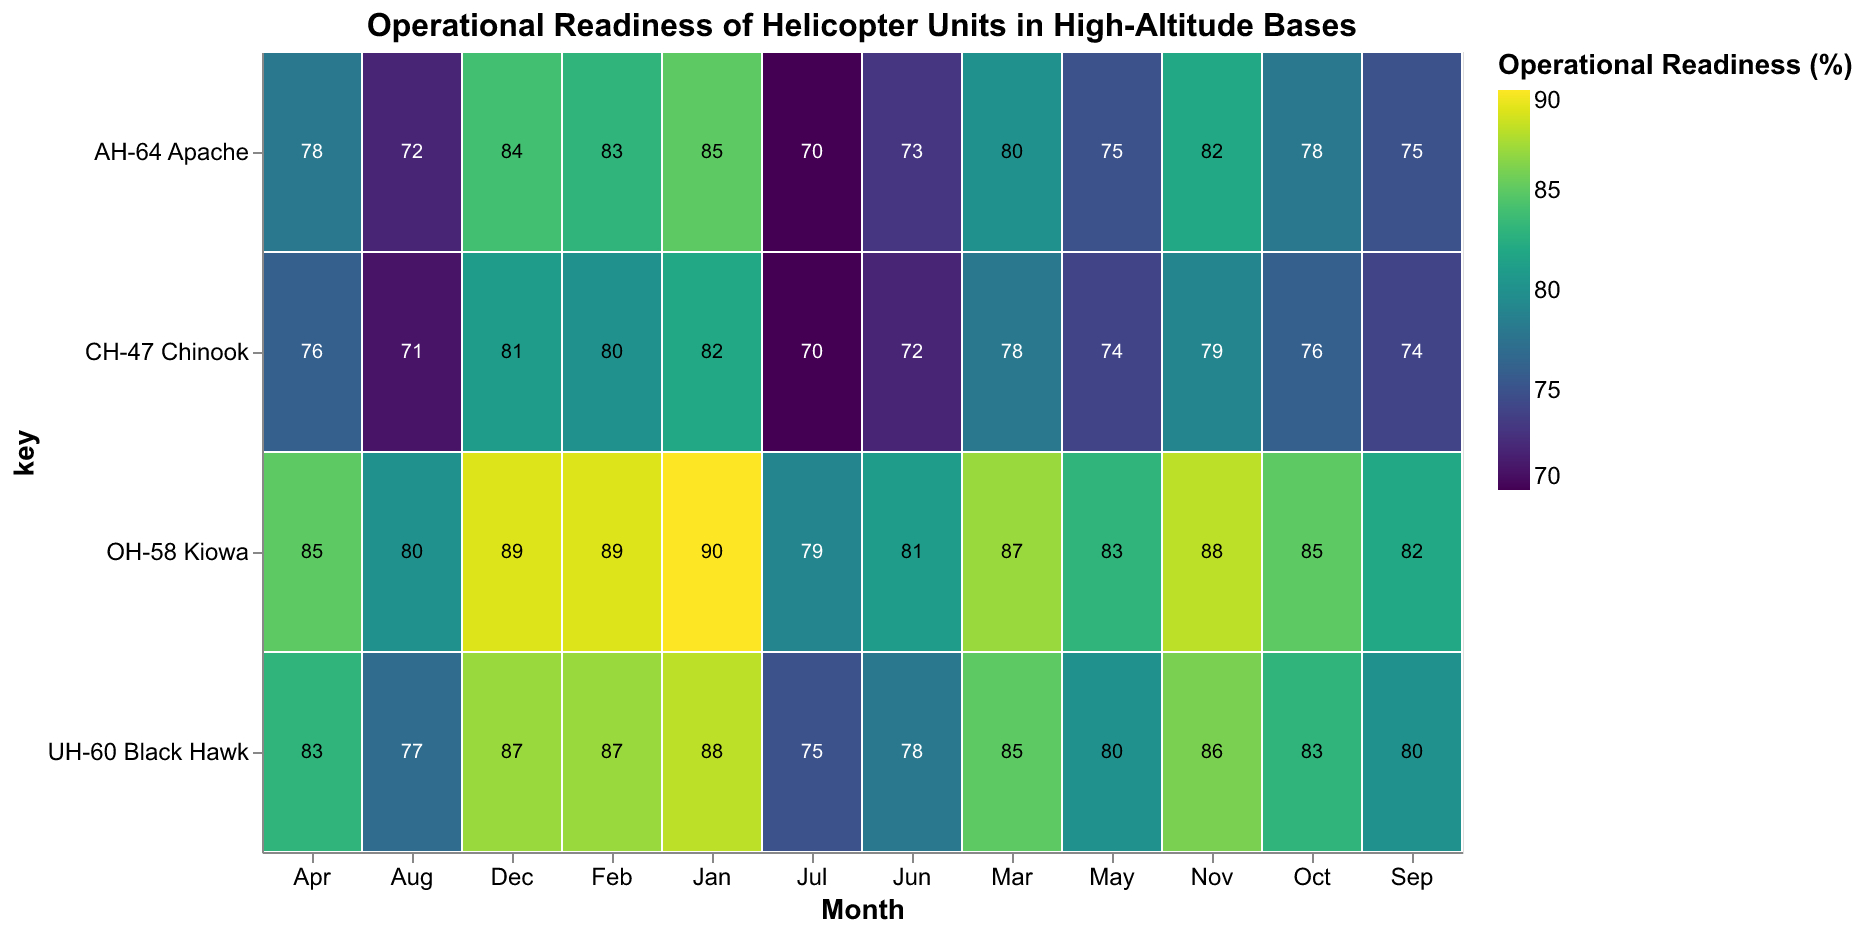How does the operational readiness of the AH-64 Apache change over the specified months? By observing the color gradation and the numeric values in the AH-64 Apache row, we see that the operational readiness starts at 85% in January, dips to a low of 70% in July, and then climbs back to 84% by December.
Answer: It decreases from 85% to 70% and then rises to 84% Which helicopter unit has the highest operational readiness in November? By looking at the values in November, the OH-58 Kiowa has the highest operational readiness at 88%.
Answer: OH-58 Kiowa What is the average operational readiness of the UH-60 Black Hawk over the 12-month period? To find the average, sum the operational readiness values for each month [88, 87, 85, 83, 80, 78, 75, 77, 80, 83, 86, 87], which gives 989. Divide this by 12 months: 989 / 12 = 82.42%.
Answer: 82.42% During which month is the CH-47 Chinook's operational readiness the lowest? The lowest operational readiness for the CH-47 Chinook is in July, with a value of 70%.
Answer: July How does the operational readiness of the OH-58 Kiowa compare to the UH-60 Black Hawk in June? In June, the OH-58 Kiowa has an operational readiness of 81% while the UH-60 Black Hawk has an operational readiness of 78%. Therefore, the OH-58 Kiowa is higher.
Answer: OH-58 Kiowa is higher Which helicopter unit consistently had the highest operational readiness each month? By considering the highest value in each month's column, the OH-58 Kiowa consistently has the highest operational readiness each month.
Answer: OH-58 Kiowa What is the trend in operational readiness for the CH-47 Chinook from January to December? Observing the CH-47 Chinook values from January (82%) to December (81%), the operational readiness shows a general decrease, hitting a low of 70% in July, before rising again towards December.
Answer: Decreasing trend with a low in July and increasing towards December Compare the operational readiness of all units in March. Which unit has the best and worst readiness? In March, the operational readiness is: AH-64 Apache (80%), UH-60 Black Hawk (85%), CH-47 Chinook (78%), OH-58 Kiowa (87%). The OH-58 Kiowa has the best readiness, and the CH-47 Chinook has the worst.
Answer: OH-58 Kiowa best, CH-47 Chinook worst What is the range of operational readiness values for the UH-60 Black Hawk across the year? The highest readiness value for the UH-60 Black Hawk is 88% (January), and the lowest is 75% (July). The range is calculated by subtracting the lowest value from the highest: 88 - 75 = 13%.
Answer: 13% Which helicopter unit has the most stable operational readiness over the year? By observing the fluctuations in the operational readiness values, the OH-58 Kiowa exhibits the most stability with values ranging from 79% (November) to 90% (January).
Answer: OH-58 Kiowa 